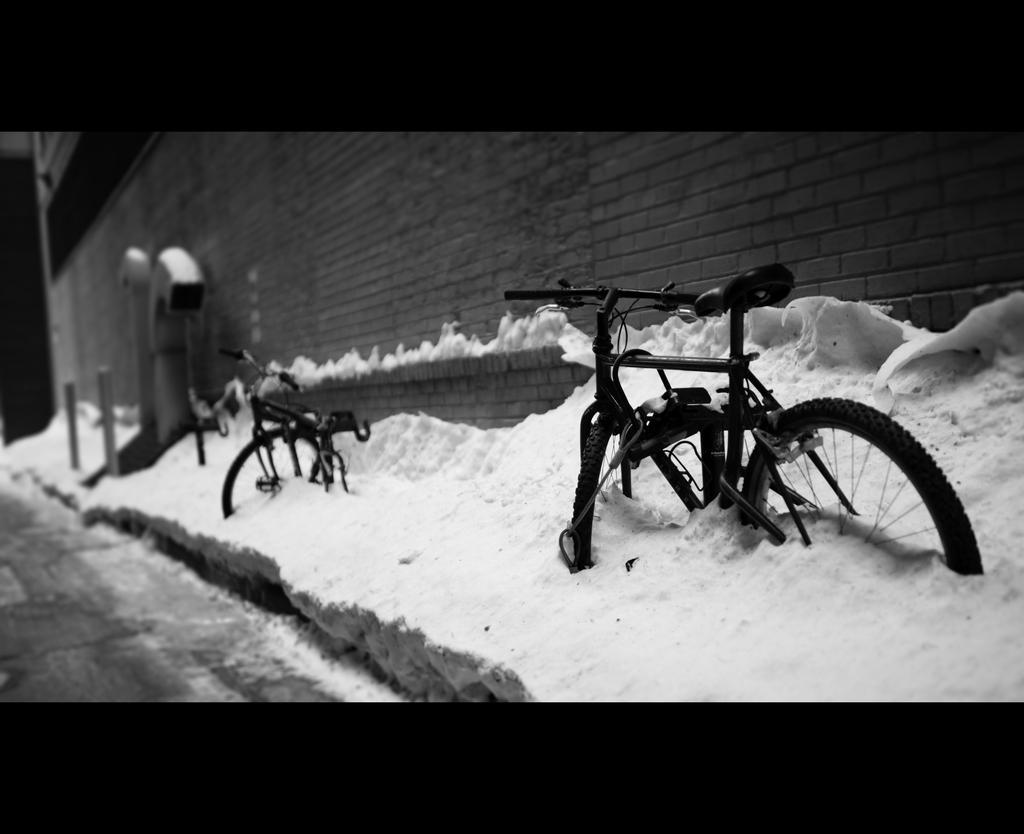In one or two sentences, can you explain what this image depicts? In this image we can see bicycles. In the background there is a wall and we can see snow. 